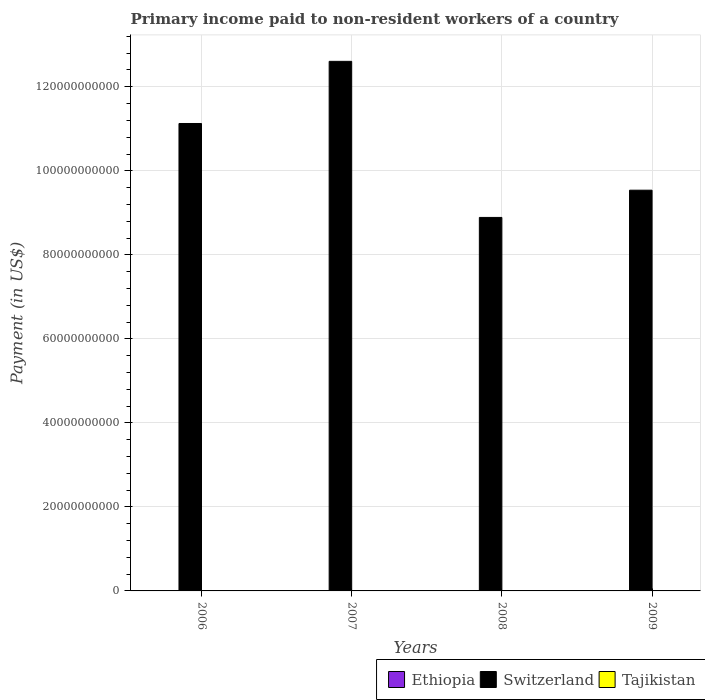How many different coloured bars are there?
Provide a short and direct response. 3. How many groups of bars are there?
Your answer should be very brief. 4. Are the number of bars per tick equal to the number of legend labels?
Offer a very short reply. Yes. Are the number of bars on each tick of the X-axis equal?
Your response must be concise. Yes. How many bars are there on the 1st tick from the left?
Give a very brief answer. 3. How many bars are there on the 1st tick from the right?
Make the answer very short. 3. What is the label of the 2nd group of bars from the left?
Keep it short and to the point. 2007. What is the amount paid to workers in Ethiopia in 2009?
Give a very brief answer. 6.50e+06. Across all years, what is the maximum amount paid to workers in Ethiopia?
Offer a very short reply. 7.65e+07. Across all years, what is the minimum amount paid to workers in Switzerland?
Provide a short and direct response. 8.89e+1. What is the total amount paid to workers in Ethiopia in the graph?
Give a very brief answer. 1.76e+08. What is the difference between the amount paid to workers in Switzerland in 2006 and that in 2007?
Offer a very short reply. -1.48e+1. What is the difference between the amount paid to workers in Switzerland in 2008 and the amount paid to workers in Tajikistan in 2006?
Ensure brevity in your answer.  8.89e+1. What is the average amount paid to workers in Ethiopia per year?
Give a very brief answer. 4.41e+07. In the year 2008, what is the difference between the amount paid to workers in Tajikistan and amount paid to workers in Ethiopia?
Make the answer very short. -1.77e+07. In how many years, is the amount paid to workers in Ethiopia greater than 100000000000 US$?
Your answer should be very brief. 0. What is the ratio of the amount paid to workers in Ethiopia in 2007 to that in 2008?
Your response must be concise. 2.04. What is the difference between the highest and the second highest amount paid to workers in Switzerland?
Provide a short and direct response. 1.48e+1. What is the difference between the highest and the lowest amount paid to workers in Tajikistan?
Offer a very short reply. 1.52e+07. Is the sum of the amount paid to workers in Switzerland in 2006 and 2009 greater than the maximum amount paid to workers in Tajikistan across all years?
Give a very brief answer. Yes. What does the 2nd bar from the left in 2006 represents?
Your answer should be compact. Switzerland. What does the 1st bar from the right in 2006 represents?
Provide a short and direct response. Tajikistan. Is it the case that in every year, the sum of the amount paid to workers in Tajikistan and amount paid to workers in Switzerland is greater than the amount paid to workers in Ethiopia?
Your answer should be very brief. Yes. How many bars are there?
Offer a very short reply. 12. Are all the bars in the graph horizontal?
Ensure brevity in your answer.  No. How many years are there in the graph?
Offer a terse response. 4. What is the difference between two consecutive major ticks on the Y-axis?
Your response must be concise. 2.00e+1. Are the values on the major ticks of Y-axis written in scientific E-notation?
Offer a very short reply. No. Does the graph contain grids?
Keep it short and to the point. Yes. Where does the legend appear in the graph?
Provide a short and direct response. Bottom right. How many legend labels are there?
Ensure brevity in your answer.  3. What is the title of the graph?
Your answer should be very brief. Primary income paid to non-resident workers of a country. What is the label or title of the Y-axis?
Your answer should be very brief. Payment (in US$). What is the Payment (in US$) in Ethiopia in 2006?
Offer a terse response. 5.58e+07. What is the Payment (in US$) in Switzerland in 2006?
Offer a very short reply. 1.11e+11. What is the Payment (in US$) in Tajikistan in 2006?
Your response must be concise. 1.24e+07. What is the Payment (in US$) of Ethiopia in 2007?
Provide a succinct answer. 7.65e+07. What is the Payment (in US$) of Switzerland in 2007?
Your answer should be compact. 1.26e+11. What is the Payment (in US$) in Tajikistan in 2007?
Provide a succinct answer. 2.24e+07. What is the Payment (in US$) in Ethiopia in 2008?
Your answer should be very brief. 3.75e+07. What is the Payment (in US$) in Switzerland in 2008?
Keep it short and to the point. 8.89e+1. What is the Payment (in US$) of Tajikistan in 2008?
Your response must be concise. 1.98e+07. What is the Payment (in US$) of Ethiopia in 2009?
Provide a short and direct response. 6.50e+06. What is the Payment (in US$) of Switzerland in 2009?
Your answer should be very brief. 9.54e+1. What is the Payment (in US$) in Tajikistan in 2009?
Ensure brevity in your answer.  7.18e+06. Across all years, what is the maximum Payment (in US$) in Ethiopia?
Offer a terse response. 7.65e+07. Across all years, what is the maximum Payment (in US$) of Switzerland?
Your response must be concise. 1.26e+11. Across all years, what is the maximum Payment (in US$) of Tajikistan?
Provide a succinct answer. 2.24e+07. Across all years, what is the minimum Payment (in US$) in Ethiopia?
Keep it short and to the point. 6.50e+06. Across all years, what is the minimum Payment (in US$) in Switzerland?
Give a very brief answer. 8.89e+1. Across all years, what is the minimum Payment (in US$) in Tajikistan?
Provide a succinct answer. 7.18e+06. What is the total Payment (in US$) of Ethiopia in the graph?
Your response must be concise. 1.76e+08. What is the total Payment (in US$) in Switzerland in the graph?
Provide a succinct answer. 4.22e+11. What is the total Payment (in US$) in Tajikistan in the graph?
Offer a terse response. 6.19e+07. What is the difference between the Payment (in US$) of Ethiopia in 2006 and that in 2007?
Offer a very short reply. -2.07e+07. What is the difference between the Payment (in US$) in Switzerland in 2006 and that in 2007?
Make the answer very short. -1.48e+1. What is the difference between the Payment (in US$) in Tajikistan in 2006 and that in 2007?
Give a very brief answer. -1.00e+07. What is the difference between the Payment (in US$) of Ethiopia in 2006 and that in 2008?
Offer a terse response. 1.83e+07. What is the difference between the Payment (in US$) of Switzerland in 2006 and that in 2008?
Offer a very short reply. 2.24e+1. What is the difference between the Payment (in US$) in Tajikistan in 2006 and that in 2008?
Provide a succinct answer. -7.42e+06. What is the difference between the Payment (in US$) of Ethiopia in 2006 and that in 2009?
Offer a terse response. 4.93e+07. What is the difference between the Payment (in US$) of Switzerland in 2006 and that in 2009?
Your response must be concise. 1.59e+1. What is the difference between the Payment (in US$) in Tajikistan in 2006 and that in 2009?
Keep it short and to the point. 5.24e+06. What is the difference between the Payment (in US$) of Ethiopia in 2007 and that in 2008?
Provide a short and direct response. 3.90e+07. What is the difference between the Payment (in US$) in Switzerland in 2007 and that in 2008?
Offer a very short reply. 3.72e+1. What is the difference between the Payment (in US$) in Tajikistan in 2007 and that in 2008?
Offer a very short reply. 2.58e+06. What is the difference between the Payment (in US$) in Ethiopia in 2007 and that in 2009?
Ensure brevity in your answer.  7.00e+07. What is the difference between the Payment (in US$) of Switzerland in 2007 and that in 2009?
Your answer should be very brief. 3.07e+1. What is the difference between the Payment (in US$) in Tajikistan in 2007 and that in 2009?
Offer a terse response. 1.52e+07. What is the difference between the Payment (in US$) of Ethiopia in 2008 and that in 2009?
Provide a short and direct response. 3.10e+07. What is the difference between the Payment (in US$) of Switzerland in 2008 and that in 2009?
Ensure brevity in your answer.  -6.48e+09. What is the difference between the Payment (in US$) in Tajikistan in 2008 and that in 2009?
Your response must be concise. 1.27e+07. What is the difference between the Payment (in US$) in Ethiopia in 2006 and the Payment (in US$) in Switzerland in 2007?
Your response must be concise. -1.26e+11. What is the difference between the Payment (in US$) in Ethiopia in 2006 and the Payment (in US$) in Tajikistan in 2007?
Provide a succinct answer. 3.33e+07. What is the difference between the Payment (in US$) in Switzerland in 2006 and the Payment (in US$) in Tajikistan in 2007?
Your answer should be very brief. 1.11e+11. What is the difference between the Payment (in US$) of Ethiopia in 2006 and the Payment (in US$) of Switzerland in 2008?
Offer a terse response. -8.88e+1. What is the difference between the Payment (in US$) in Ethiopia in 2006 and the Payment (in US$) in Tajikistan in 2008?
Your response must be concise. 3.59e+07. What is the difference between the Payment (in US$) in Switzerland in 2006 and the Payment (in US$) in Tajikistan in 2008?
Offer a terse response. 1.11e+11. What is the difference between the Payment (in US$) in Ethiopia in 2006 and the Payment (in US$) in Switzerland in 2009?
Ensure brevity in your answer.  -9.53e+1. What is the difference between the Payment (in US$) in Ethiopia in 2006 and the Payment (in US$) in Tajikistan in 2009?
Keep it short and to the point. 4.86e+07. What is the difference between the Payment (in US$) in Switzerland in 2006 and the Payment (in US$) in Tajikistan in 2009?
Your response must be concise. 1.11e+11. What is the difference between the Payment (in US$) in Ethiopia in 2007 and the Payment (in US$) in Switzerland in 2008?
Your response must be concise. -8.88e+1. What is the difference between the Payment (in US$) in Ethiopia in 2007 and the Payment (in US$) in Tajikistan in 2008?
Offer a terse response. 5.66e+07. What is the difference between the Payment (in US$) in Switzerland in 2007 and the Payment (in US$) in Tajikistan in 2008?
Your answer should be very brief. 1.26e+11. What is the difference between the Payment (in US$) of Ethiopia in 2007 and the Payment (in US$) of Switzerland in 2009?
Make the answer very short. -9.53e+1. What is the difference between the Payment (in US$) in Ethiopia in 2007 and the Payment (in US$) in Tajikistan in 2009?
Ensure brevity in your answer.  6.93e+07. What is the difference between the Payment (in US$) of Switzerland in 2007 and the Payment (in US$) of Tajikistan in 2009?
Offer a terse response. 1.26e+11. What is the difference between the Payment (in US$) in Ethiopia in 2008 and the Payment (in US$) in Switzerland in 2009?
Provide a short and direct response. -9.54e+1. What is the difference between the Payment (in US$) in Ethiopia in 2008 and the Payment (in US$) in Tajikistan in 2009?
Your response must be concise. 3.03e+07. What is the difference between the Payment (in US$) in Switzerland in 2008 and the Payment (in US$) in Tajikistan in 2009?
Make the answer very short. 8.89e+1. What is the average Payment (in US$) in Ethiopia per year?
Provide a short and direct response. 4.41e+07. What is the average Payment (in US$) of Switzerland per year?
Offer a terse response. 1.05e+11. What is the average Payment (in US$) of Tajikistan per year?
Ensure brevity in your answer.  1.55e+07. In the year 2006, what is the difference between the Payment (in US$) of Ethiopia and Payment (in US$) of Switzerland?
Your response must be concise. -1.11e+11. In the year 2006, what is the difference between the Payment (in US$) in Ethiopia and Payment (in US$) in Tajikistan?
Make the answer very short. 4.33e+07. In the year 2006, what is the difference between the Payment (in US$) of Switzerland and Payment (in US$) of Tajikistan?
Your response must be concise. 1.11e+11. In the year 2007, what is the difference between the Payment (in US$) of Ethiopia and Payment (in US$) of Switzerland?
Ensure brevity in your answer.  -1.26e+11. In the year 2007, what is the difference between the Payment (in US$) in Ethiopia and Payment (in US$) in Tajikistan?
Your answer should be very brief. 5.40e+07. In the year 2007, what is the difference between the Payment (in US$) in Switzerland and Payment (in US$) in Tajikistan?
Keep it short and to the point. 1.26e+11. In the year 2008, what is the difference between the Payment (in US$) in Ethiopia and Payment (in US$) in Switzerland?
Your response must be concise. -8.89e+1. In the year 2008, what is the difference between the Payment (in US$) in Ethiopia and Payment (in US$) in Tajikistan?
Ensure brevity in your answer.  1.77e+07. In the year 2008, what is the difference between the Payment (in US$) of Switzerland and Payment (in US$) of Tajikistan?
Keep it short and to the point. 8.89e+1. In the year 2009, what is the difference between the Payment (in US$) in Ethiopia and Payment (in US$) in Switzerland?
Ensure brevity in your answer.  -9.54e+1. In the year 2009, what is the difference between the Payment (in US$) in Ethiopia and Payment (in US$) in Tajikistan?
Make the answer very short. -6.85e+05. In the year 2009, what is the difference between the Payment (in US$) in Switzerland and Payment (in US$) in Tajikistan?
Ensure brevity in your answer.  9.54e+1. What is the ratio of the Payment (in US$) of Ethiopia in 2006 to that in 2007?
Keep it short and to the point. 0.73. What is the ratio of the Payment (in US$) in Switzerland in 2006 to that in 2007?
Give a very brief answer. 0.88. What is the ratio of the Payment (in US$) of Tajikistan in 2006 to that in 2007?
Provide a short and direct response. 0.55. What is the ratio of the Payment (in US$) in Ethiopia in 2006 to that in 2008?
Provide a succinct answer. 1.49. What is the ratio of the Payment (in US$) of Switzerland in 2006 to that in 2008?
Provide a short and direct response. 1.25. What is the ratio of the Payment (in US$) in Tajikistan in 2006 to that in 2008?
Give a very brief answer. 0.63. What is the ratio of the Payment (in US$) of Ethiopia in 2006 to that in 2009?
Make the answer very short. 8.58. What is the ratio of the Payment (in US$) of Switzerland in 2006 to that in 2009?
Make the answer very short. 1.17. What is the ratio of the Payment (in US$) of Tajikistan in 2006 to that in 2009?
Provide a succinct answer. 1.73. What is the ratio of the Payment (in US$) of Ethiopia in 2007 to that in 2008?
Your answer should be compact. 2.04. What is the ratio of the Payment (in US$) in Switzerland in 2007 to that in 2008?
Your answer should be very brief. 1.42. What is the ratio of the Payment (in US$) in Tajikistan in 2007 to that in 2008?
Ensure brevity in your answer.  1.13. What is the ratio of the Payment (in US$) in Ethiopia in 2007 to that in 2009?
Offer a terse response. 11.76. What is the ratio of the Payment (in US$) in Switzerland in 2007 to that in 2009?
Provide a succinct answer. 1.32. What is the ratio of the Payment (in US$) in Tajikistan in 2007 to that in 2009?
Provide a succinct answer. 3.12. What is the ratio of the Payment (in US$) in Ethiopia in 2008 to that in 2009?
Offer a terse response. 5.77. What is the ratio of the Payment (in US$) of Switzerland in 2008 to that in 2009?
Provide a succinct answer. 0.93. What is the ratio of the Payment (in US$) in Tajikistan in 2008 to that in 2009?
Offer a very short reply. 2.76. What is the difference between the highest and the second highest Payment (in US$) of Ethiopia?
Give a very brief answer. 2.07e+07. What is the difference between the highest and the second highest Payment (in US$) in Switzerland?
Your answer should be compact. 1.48e+1. What is the difference between the highest and the second highest Payment (in US$) of Tajikistan?
Offer a terse response. 2.58e+06. What is the difference between the highest and the lowest Payment (in US$) in Ethiopia?
Offer a terse response. 7.00e+07. What is the difference between the highest and the lowest Payment (in US$) of Switzerland?
Provide a succinct answer. 3.72e+1. What is the difference between the highest and the lowest Payment (in US$) in Tajikistan?
Keep it short and to the point. 1.52e+07. 